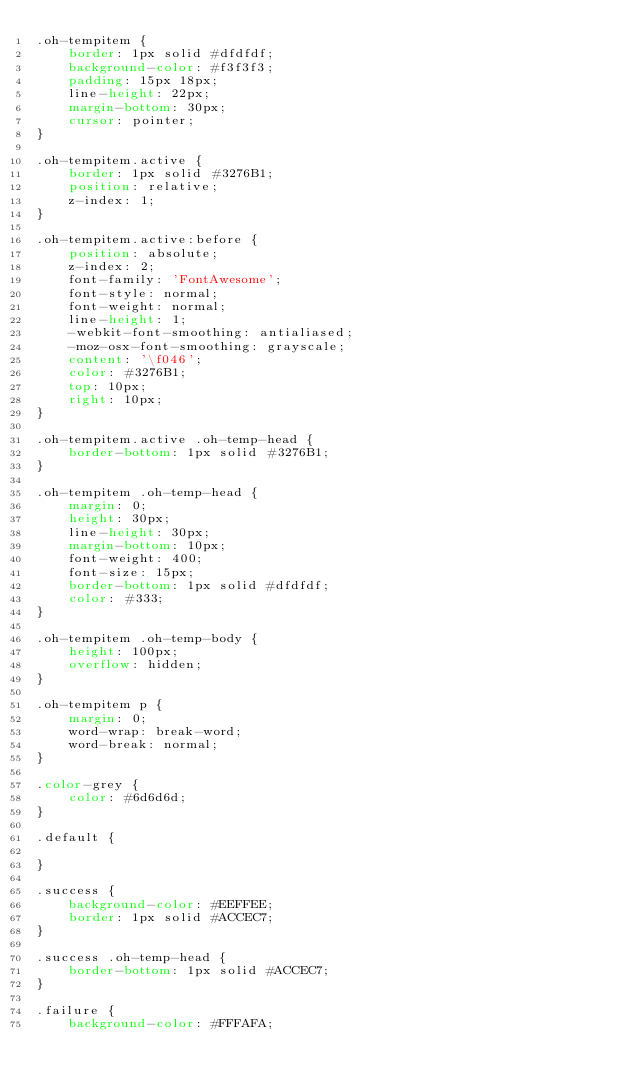Convert code to text. <code><loc_0><loc_0><loc_500><loc_500><_CSS_>.oh-tempitem {
    border: 1px solid #dfdfdf;
    background-color: #f3f3f3;
    padding: 15px 18px;
    line-height: 22px;
    margin-bottom: 30px;
    cursor: pointer;
}

.oh-tempitem.active {
    border: 1px solid #3276B1;
    position: relative;
    z-index: 1;
}

.oh-tempitem.active:before {
    position: absolute;
    z-index: 2;
    font-family: 'FontAwesome';
    font-style: normal;
    font-weight: normal;
    line-height: 1;
    -webkit-font-smoothing: antialiased;
    -moz-osx-font-smoothing: grayscale;
    content: '\f046';
    color: #3276B1;
    top: 10px;
    right: 10px;
}

.oh-tempitem.active .oh-temp-head {
    border-bottom: 1px solid #3276B1;
}

.oh-tempitem .oh-temp-head {
    margin: 0;
    height: 30px;
    line-height: 30px;
    margin-bottom: 10px;
    font-weight: 400;
    font-size: 15px;
    border-bottom: 1px solid #dfdfdf;
    color: #333;
}

.oh-tempitem .oh-temp-body {
    height: 100px;
    overflow: hidden;
}

.oh-tempitem p {
    margin: 0;
    word-wrap: break-word;
    word-break: normal;
}

.color-grey {
    color: #6d6d6d;
}

.default {

}

.success {
    background-color: #EEFFEE;
    border: 1px solid #ACCEC7;
}

.success .oh-temp-head {
    border-bottom: 1px solid #ACCEC7;
}

.failure {
    background-color: #FFFAFA;</code> 